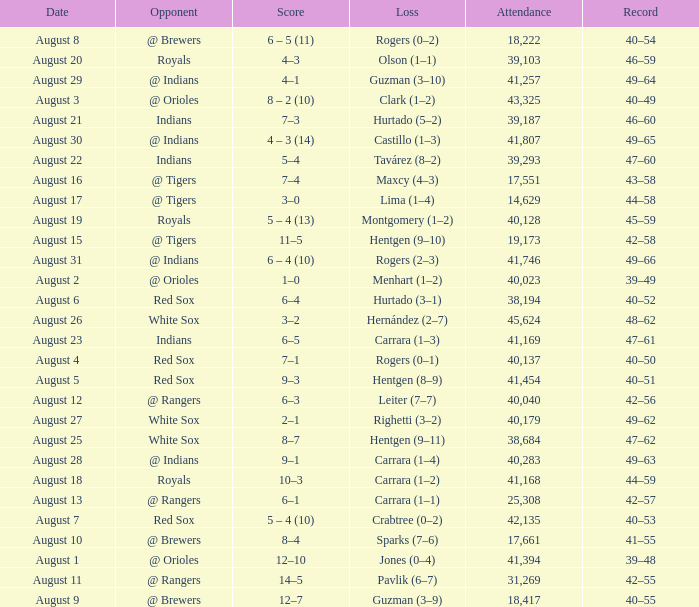Who did they play on August 12? @ Rangers. 